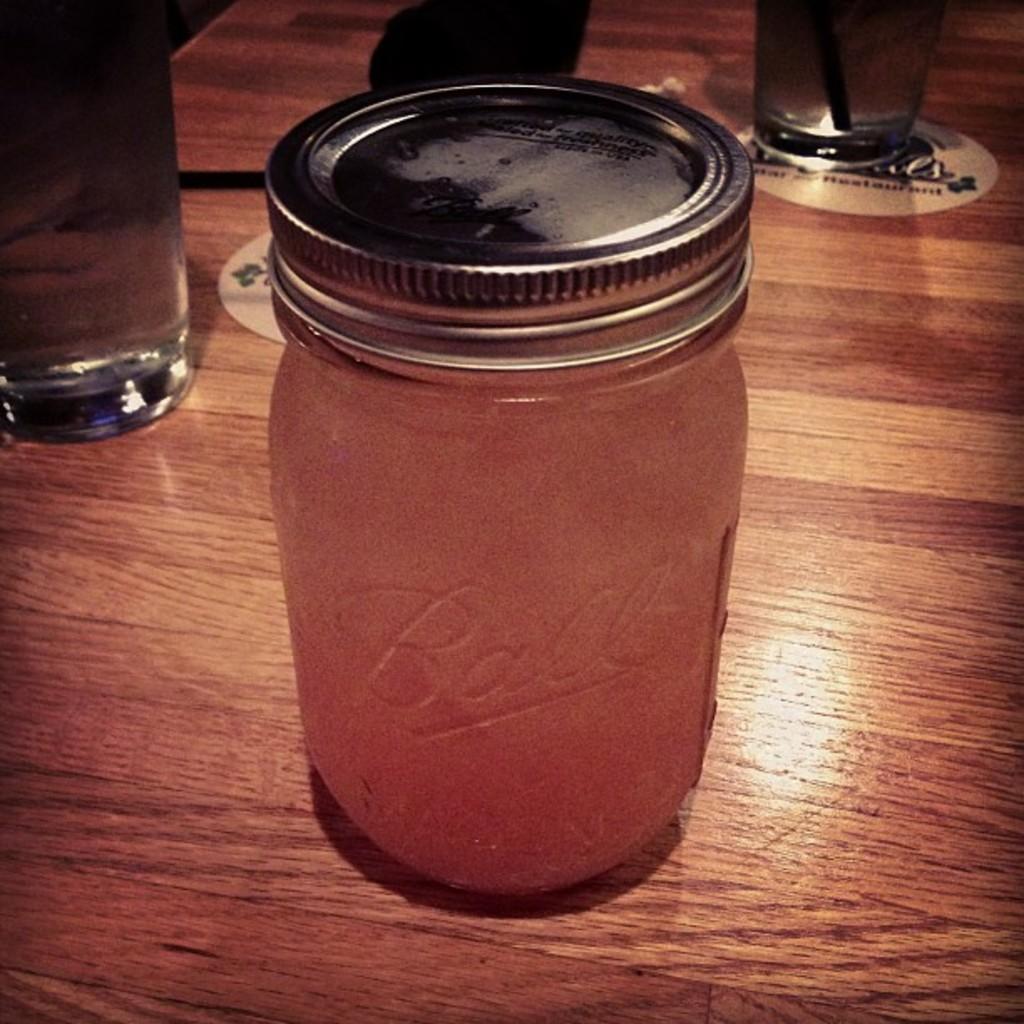Please provide a concise description of this image. In the image there is a wooden surface. In the middle of the surface there is a glass bottle with lid. Behind the bottle there are glasses. 